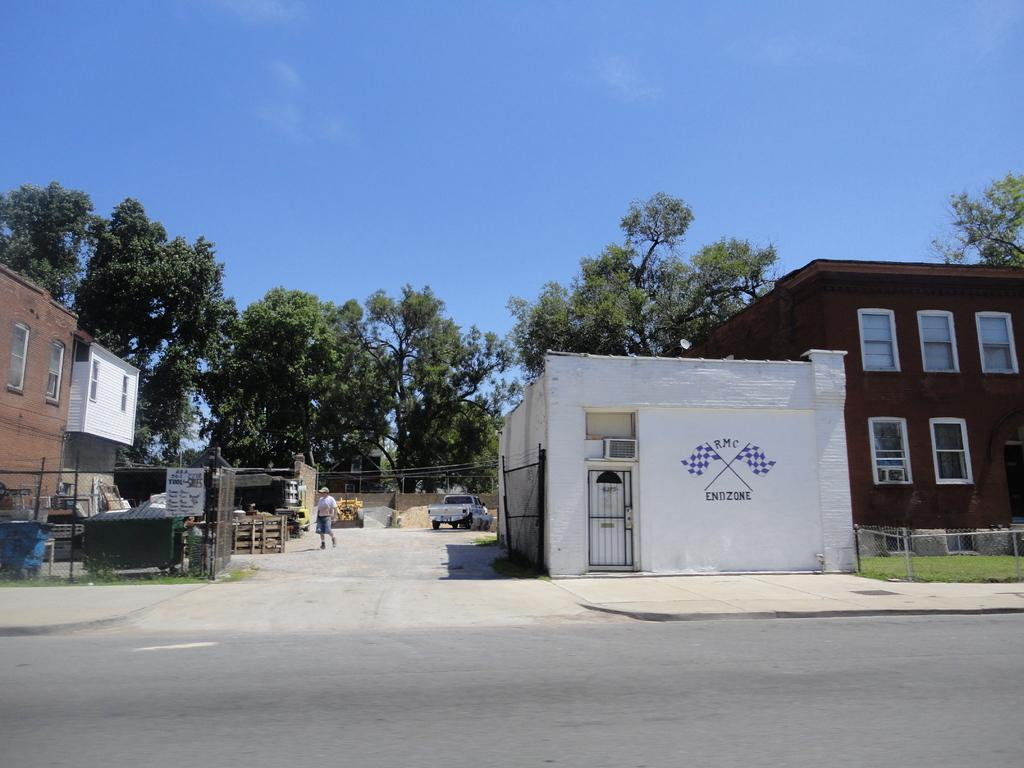What is the main feature of the image? There is a road in the image. What is happening on the road? A vehicle is present on the road, and there is a person walking on the road. What else can be seen in the image besides the road? There are buildings, trees, and the sky is clear in the image. What type of station can be seen in the image? There is no station present in the image. What fact is being illustrated in the image? The image does not illustrate a specific fact; it is a scene featuring a road, a vehicle, a person walking, buildings, trees, and a clear sky. 